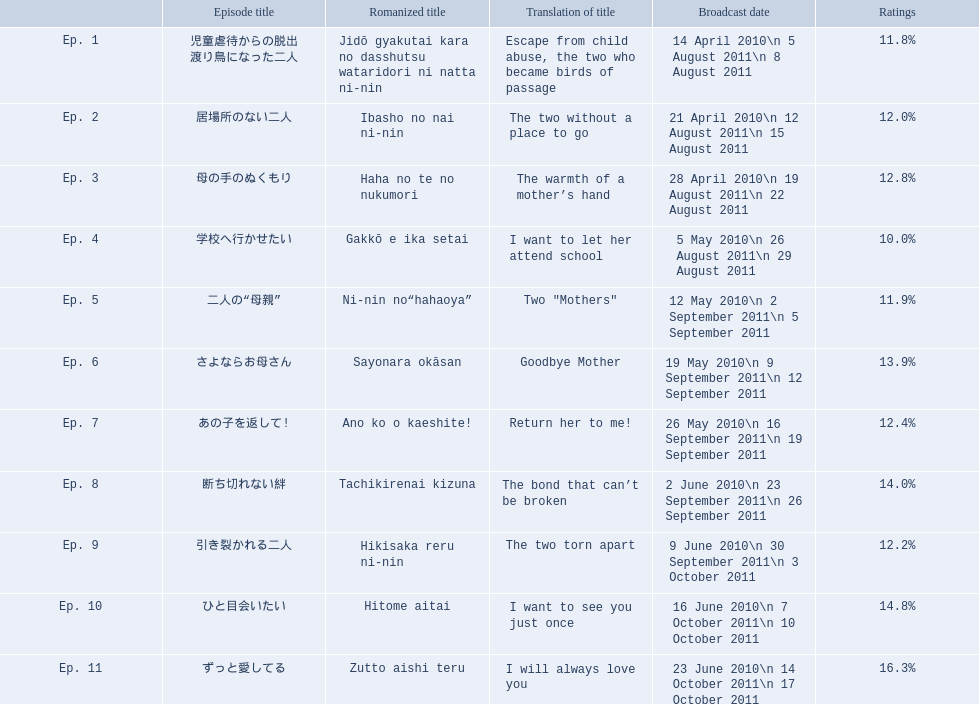What percentages of ratings does each episode have? 11.8%, 12.0%, 12.8%, 10.0%, 11.9%, 13.9%, 12.4%, 14.0%, 12.2%, 14.8%, 16.3%. Which episode received the top rating? 16.3%. Which episode obtained a 16.3% rating? ずっと愛してる. 